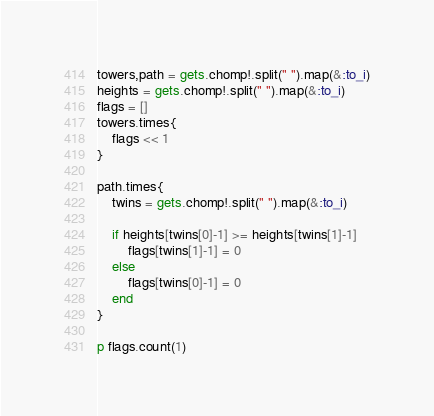<code> <loc_0><loc_0><loc_500><loc_500><_Ruby_>towers,path = gets.chomp!.split(" ").map(&:to_i)
heights = gets.chomp!.split(" ").map(&:to_i)
flags = []
towers.times{
    flags << 1
}

path.times{
    twins = gets.chomp!.split(" ").map(&:to_i)

    if heights[twins[0]-1] >= heights[twins[1]-1]
        flags[twins[1]-1] = 0
    else
        flags[twins[0]-1] = 0
    end
}

p flags.count(1)</code> 